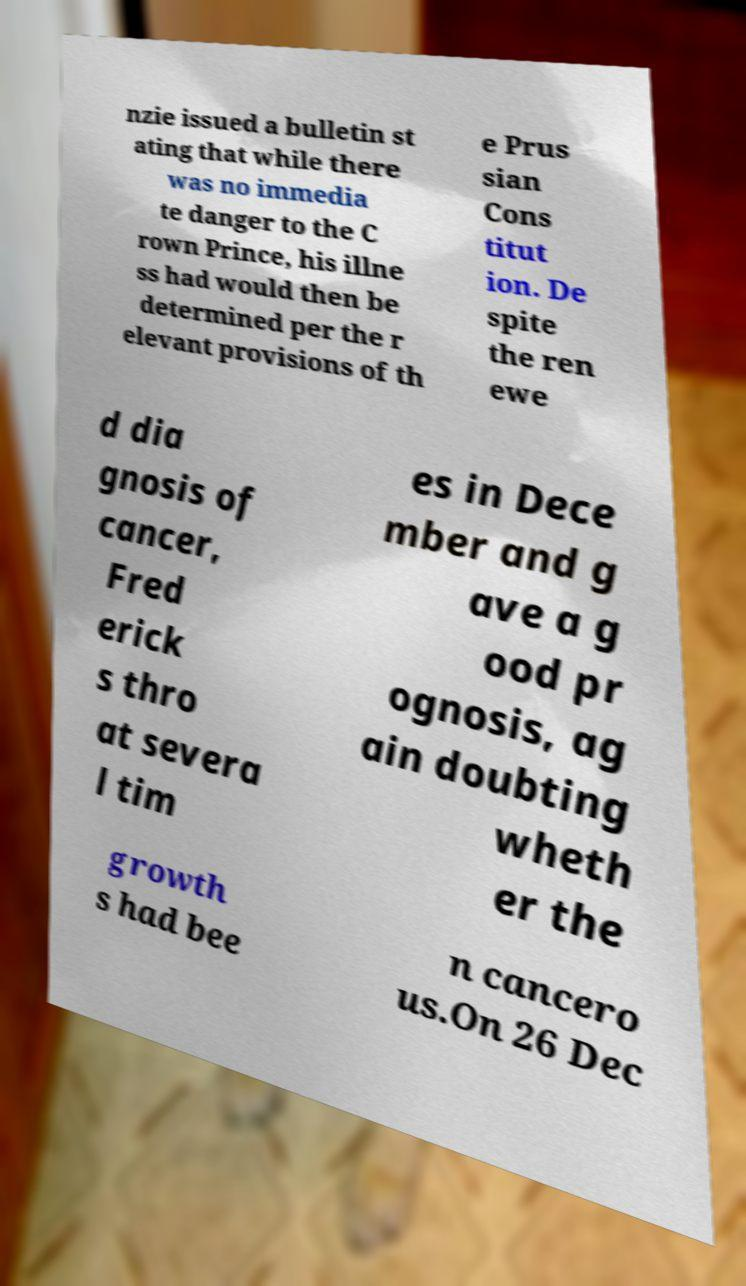Could you extract and type out the text from this image? nzie issued a bulletin st ating that while there was no immedia te danger to the C rown Prince, his illne ss had would then be determined per the r elevant provisions of th e Prus sian Cons titut ion. De spite the ren ewe d dia gnosis of cancer, Fred erick s thro at severa l tim es in Dece mber and g ave a g ood pr ognosis, ag ain doubting wheth er the growth s had bee n cancero us.On 26 Dec 